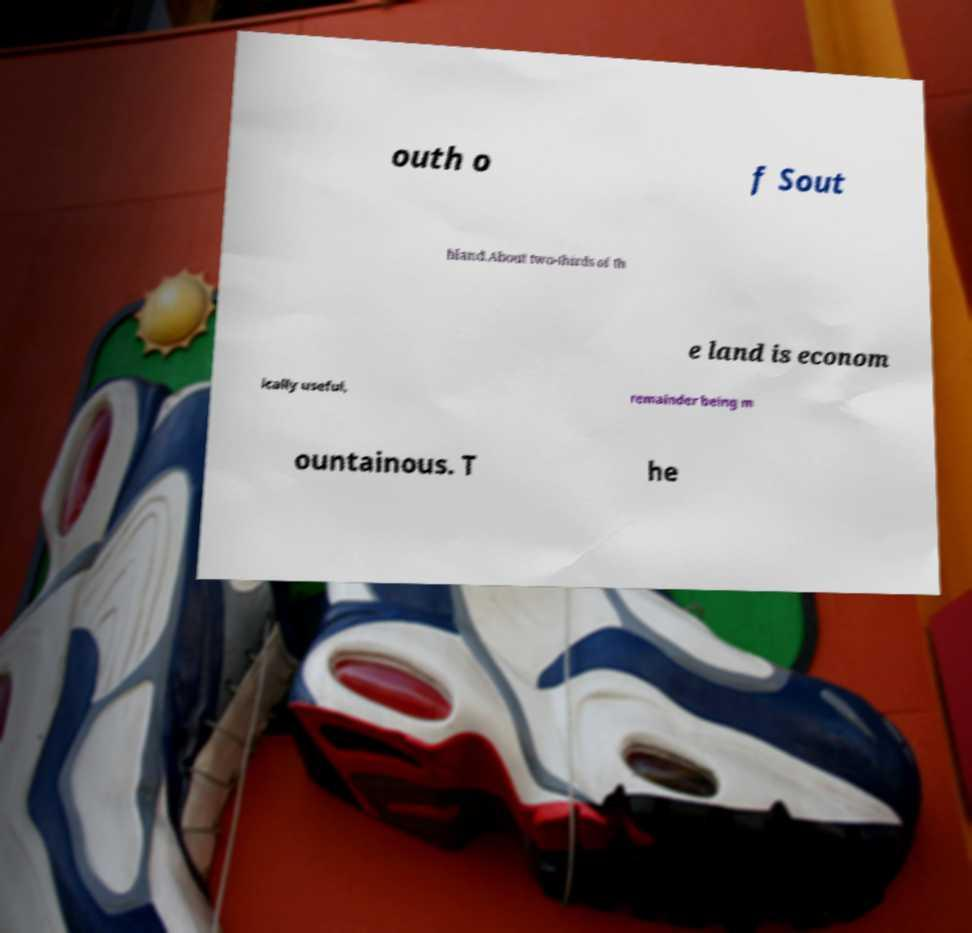Could you assist in decoding the text presented in this image and type it out clearly? outh o f Sout hland.About two-thirds of th e land is econom ically useful, remainder being m ountainous. T he 